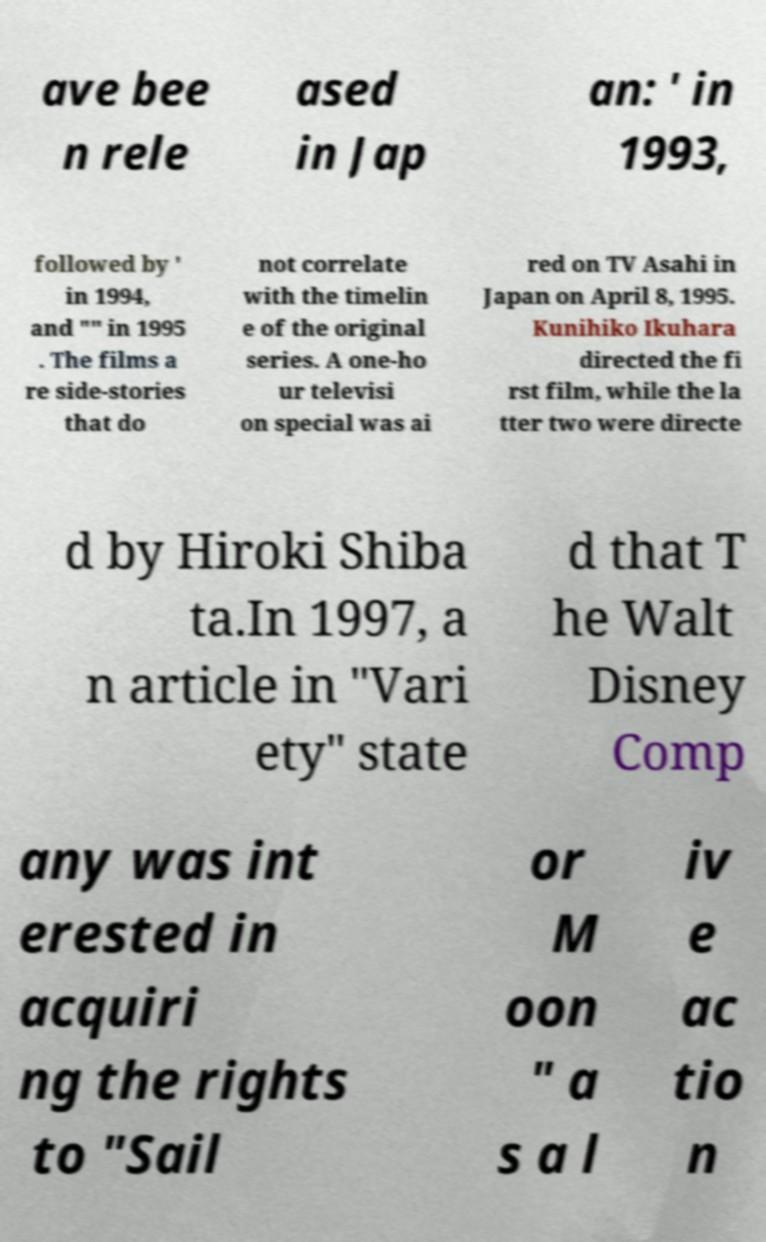Please identify and transcribe the text found in this image. ave bee n rele ased in Jap an: ' in 1993, followed by ' in 1994, and "" in 1995 . The films a re side-stories that do not correlate with the timelin e of the original series. A one-ho ur televisi on special was ai red on TV Asahi in Japan on April 8, 1995. Kunihiko Ikuhara directed the fi rst film, while the la tter two were directe d by Hiroki Shiba ta.In 1997, a n article in "Vari ety" state d that T he Walt Disney Comp any was int erested in acquiri ng the rights to "Sail or M oon " a s a l iv e ac tio n 